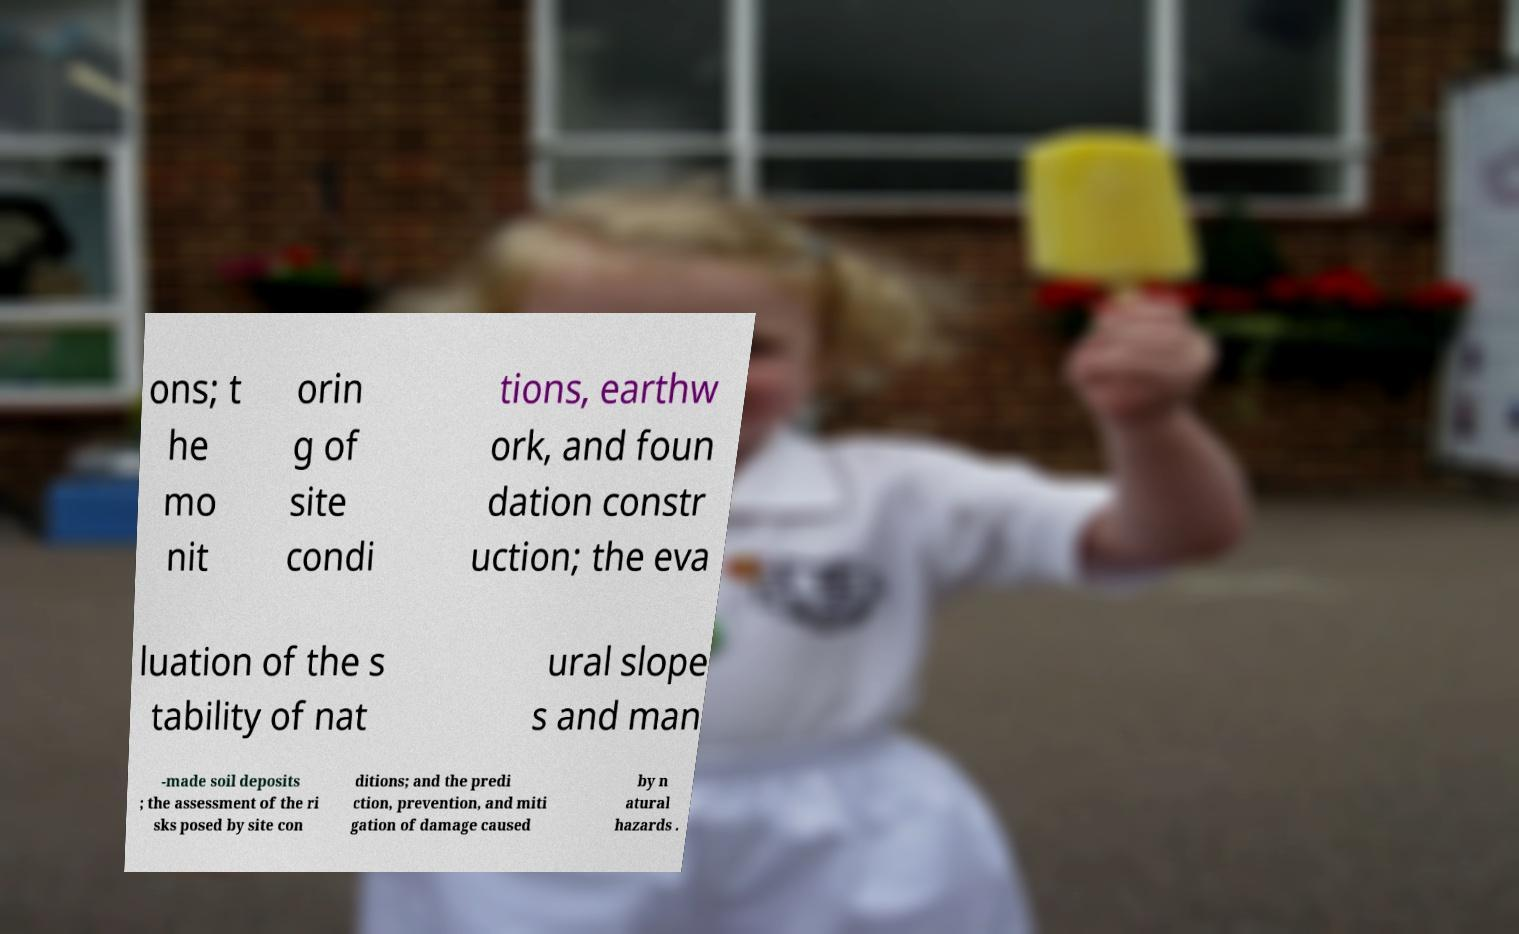I need the written content from this picture converted into text. Can you do that? ons; t he mo nit orin g of site condi tions, earthw ork, and foun dation constr uction; the eva luation of the s tability of nat ural slope s and man -made soil deposits ; the assessment of the ri sks posed by site con ditions; and the predi ction, prevention, and miti gation of damage caused by n atural hazards . 